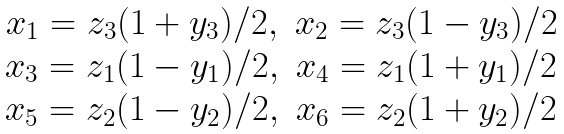Convert formula to latex. <formula><loc_0><loc_0><loc_500><loc_500>\begin{array} { c c } x _ { 1 } = z _ { 3 } ( 1 + y _ { 3 } ) / 2 , & x _ { 2 } = z _ { 3 } ( 1 - y _ { 3 } ) / 2 \\ x _ { 3 } = z _ { 1 } ( 1 - y _ { 1 } ) / 2 , & x _ { 4 } = z _ { 1 } ( 1 + y _ { 1 } ) / 2 \\ x _ { 5 } = z _ { 2 } ( 1 - y _ { 2 } ) / 2 , & x _ { 6 } = z _ { 2 } ( 1 + y _ { 2 } ) / 2 \\ \end{array}</formula> 